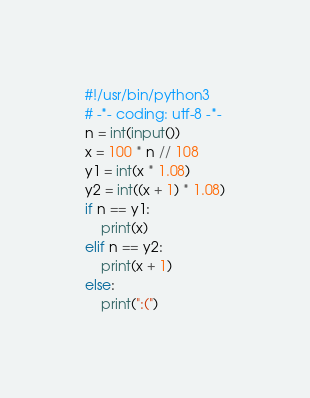<code> <loc_0><loc_0><loc_500><loc_500><_Python_>#!/usr/bin/python3
# -*- coding: utf-8 -*-
n = int(input())
x = 100 * n // 108
y1 = int(x * 1.08)
y2 = int((x + 1) * 1.08)
if n == y1:
    print(x)
elif n == y2:
    print(x + 1)
else:
    print(":(")</code> 